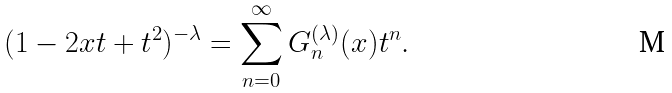Convert formula to latex. <formula><loc_0><loc_0><loc_500><loc_500>( 1 - 2 x t + t ^ { 2 } ) ^ { - \lambda } = \sum _ { n = 0 } ^ { \infty } G _ { n } ^ { ( \lambda ) } ( x ) t ^ { n } .</formula> 